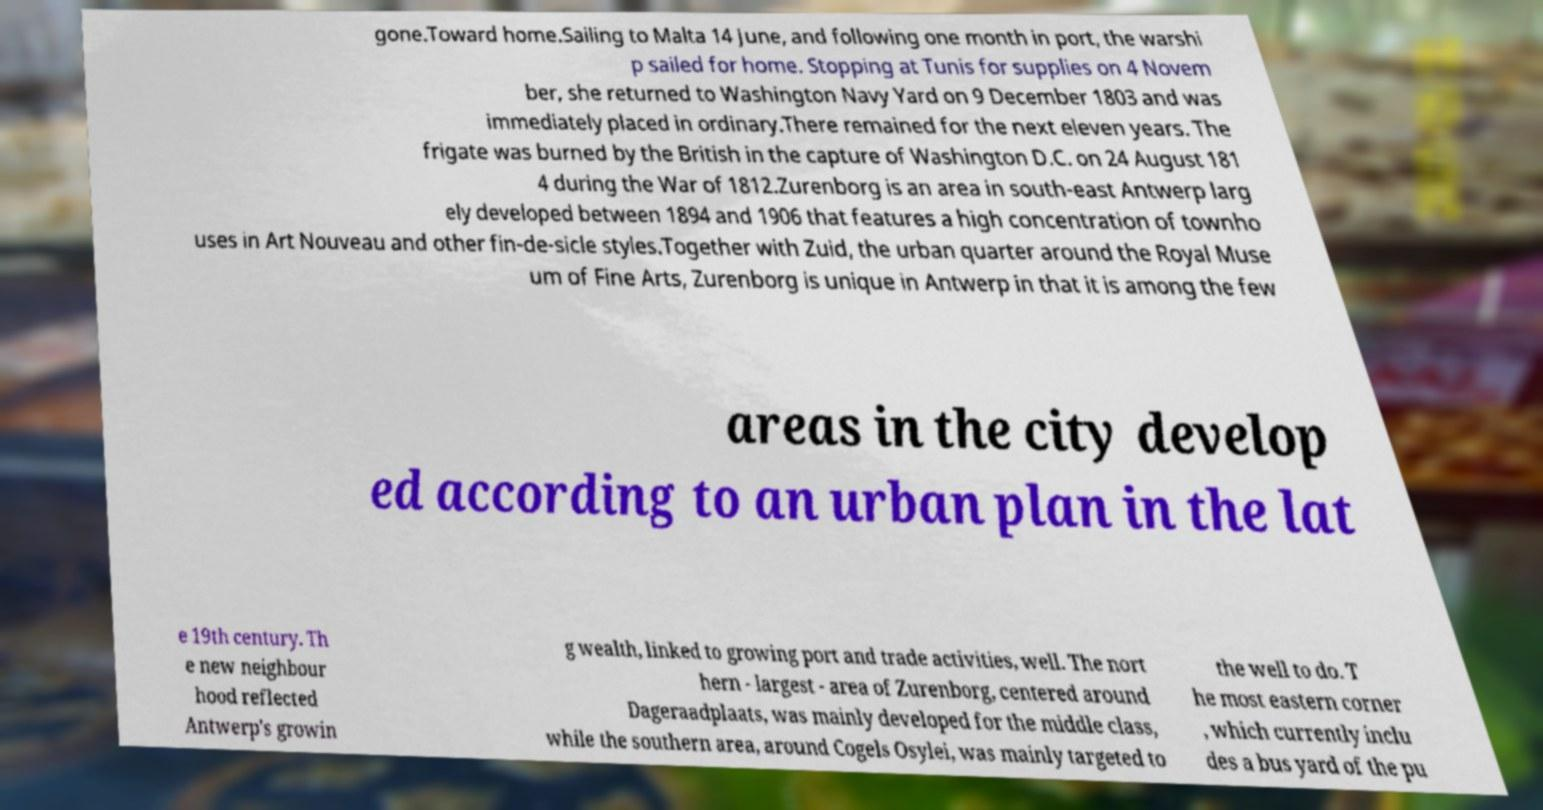Could you extract and type out the text from this image? gone.Toward home.Sailing to Malta 14 June, and following one month in port, the warshi p sailed for home. Stopping at Tunis for supplies on 4 Novem ber, she returned to Washington Navy Yard on 9 December 1803 and was immediately placed in ordinary.There remained for the next eleven years. The frigate was burned by the British in the capture of Washington D.C. on 24 August 181 4 during the War of 1812.Zurenborg is an area in south-east Antwerp larg ely developed between 1894 and 1906 that features a high concentration of townho uses in Art Nouveau and other fin-de-sicle styles.Together with Zuid, the urban quarter around the Royal Muse um of Fine Arts, Zurenborg is unique in Antwerp in that it is among the few areas in the city develop ed according to an urban plan in the lat e 19th century. Th e new neighbour hood reflected Antwerp's growin g wealth, linked to growing port and trade activities, well. The nort hern - largest - area of Zurenborg, centered around Dageraadplaats, was mainly developed for the middle class, while the southern area, around Cogels Osylei, was mainly targeted to the well to do. T he most eastern corner , which currently inclu des a bus yard of the pu 